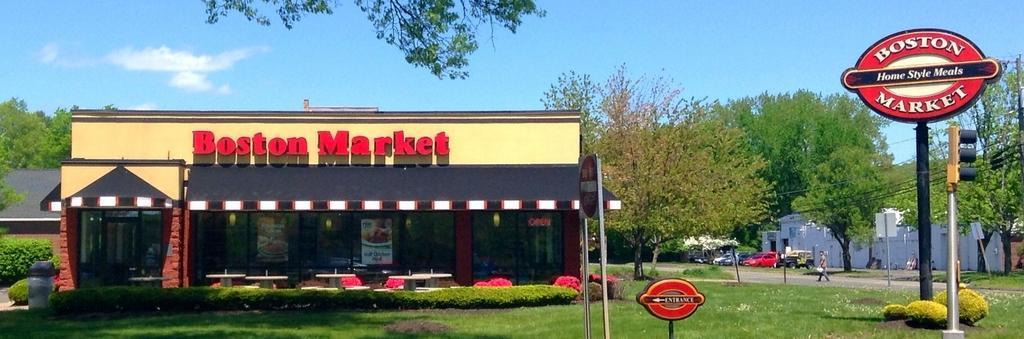Can you describe this image briefly? In the picture we can see a restaurant with glass walls and door to it and name of the restaurant is Boston market and near it we can see plants and grass surface and beside it we can see a pole with a board on it we can see a name Boston market and behind it we can see some trees and a man walking on the path and behind him we can see some cars are parked near the tree and in the background we can see the sky with clouds. 